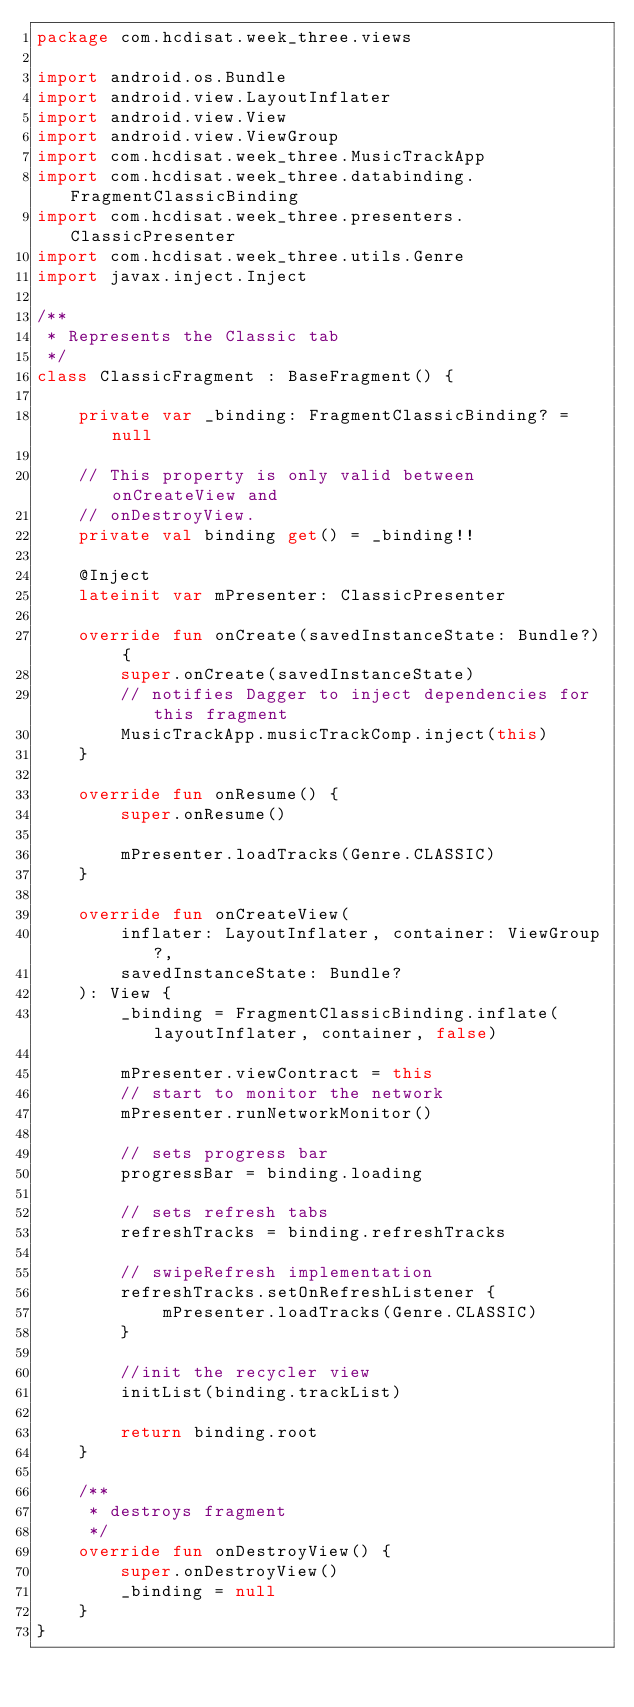<code> <loc_0><loc_0><loc_500><loc_500><_Kotlin_>package com.hcdisat.week_three.views

import android.os.Bundle
import android.view.LayoutInflater
import android.view.View
import android.view.ViewGroup
import com.hcdisat.week_three.MusicTrackApp
import com.hcdisat.week_three.databinding.FragmentClassicBinding
import com.hcdisat.week_three.presenters.ClassicPresenter
import com.hcdisat.week_three.utils.Genre
import javax.inject.Inject

/**
 * Represents the Classic tab
 */
class ClassicFragment : BaseFragment() {

    private var _binding: FragmentClassicBinding? = null

    // This property is only valid between onCreateView and
    // onDestroyView.
    private val binding get() = _binding!!

    @Inject
    lateinit var mPresenter: ClassicPresenter

    override fun onCreate(savedInstanceState: Bundle?) {
        super.onCreate(savedInstanceState)
        // notifies Dagger to inject dependencies for this fragment
        MusicTrackApp.musicTrackComp.inject(this)
    }

    override fun onResume() {
        super.onResume()

        mPresenter.loadTracks(Genre.CLASSIC)
    }

    override fun onCreateView(
        inflater: LayoutInflater, container: ViewGroup?,
        savedInstanceState: Bundle?
    ): View {
        _binding = FragmentClassicBinding.inflate(layoutInflater, container, false)

        mPresenter.viewContract = this
        // start to monitor the network
        mPresenter.runNetworkMonitor()

        // sets progress bar
        progressBar = binding.loading

        // sets refresh tabs
        refreshTracks = binding.refreshTracks

        // swipeRefresh implementation
        refreshTracks.setOnRefreshListener {
            mPresenter.loadTracks(Genre.CLASSIC)
        }

        //init the recycler view
        initList(binding.trackList)

        return binding.root
    }

    /**
     * destroys fragment
     */
    override fun onDestroyView() {
        super.onDestroyView()
        _binding = null
    }
}</code> 